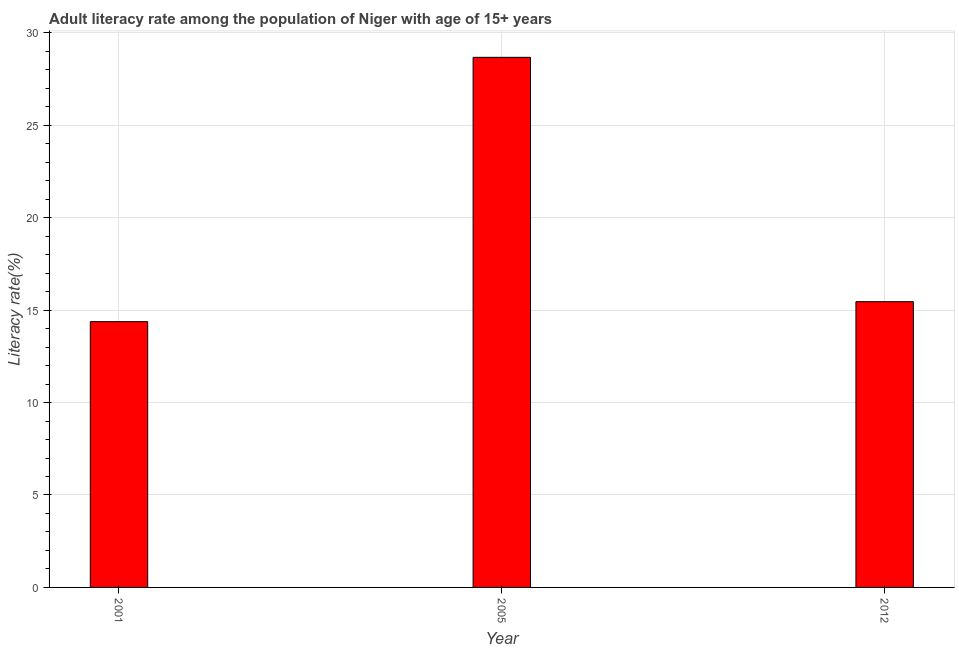Does the graph contain any zero values?
Provide a short and direct response. No. Does the graph contain grids?
Your answer should be compact. Yes. What is the title of the graph?
Your answer should be compact. Adult literacy rate among the population of Niger with age of 15+ years. What is the label or title of the X-axis?
Keep it short and to the point. Year. What is the label or title of the Y-axis?
Provide a short and direct response. Literacy rate(%). What is the adult literacy rate in 2001?
Ensure brevity in your answer.  14.38. Across all years, what is the maximum adult literacy rate?
Give a very brief answer. 28.67. Across all years, what is the minimum adult literacy rate?
Keep it short and to the point. 14.38. What is the sum of the adult literacy rate?
Offer a very short reply. 58.51. What is the difference between the adult literacy rate in 2001 and 2012?
Your answer should be compact. -1.08. What is the average adult literacy rate per year?
Your answer should be compact. 19.5. What is the median adult literacy rate?
Your answer should be very brief. 15.46. In how many years, is the adult literacy rate greater than 6 %?
Provide a succinct answer. 3. What is the ratio of the adult literacy rate in 2001 to that in 2012?
Provide a short and direct response. 0.93. Is the difference between the adult literacy rate in 2001 and 2012 greater than the difference between any two years?
Keep it short and to the point. No. What is the difference between the highest and the second highest adult literacy rate?
Keep it short and to the point. 13.22. How many bars are there?
Provide a succinct answer. 3. Are all the bars in the graph horizontal?
Ensure brevity in your answer.  No. How many years are there in the graph?
Offer a terse response. 3. What is the Literacy rate(%) in 2001?
Make the answer very short. 14.38. What is the Literacy rate(%) in 2005?
Your answer should be compact. 28.67. What is the Literacy rate(%) in 2012?
Your answer should be very brief. 15.46. What is the difference between the Literacy rate(%) in 2001 and 2005?
Your answer should be compact. -14.3. What is the difference between the Literacy rate(%) in 2001 and 2012?
Your answer should be compact. -1.08. What is the difference between the Literacy rate(%) in 2005 and 2012?
Ensure brevity in your answer.  13.22. What is the ratio of the Literacy rate(%) in 2001 to that in 2005?
Provide a short and direct response. 0.5. What is the ratio of the Literacy rate(%) in 2001 to that in 2012?
Provide a succinct answer. 0.93. What is the ratio of the Literacy rate(%) in 2005 to that in 2012?
Your answer should be compact. 1.85. 